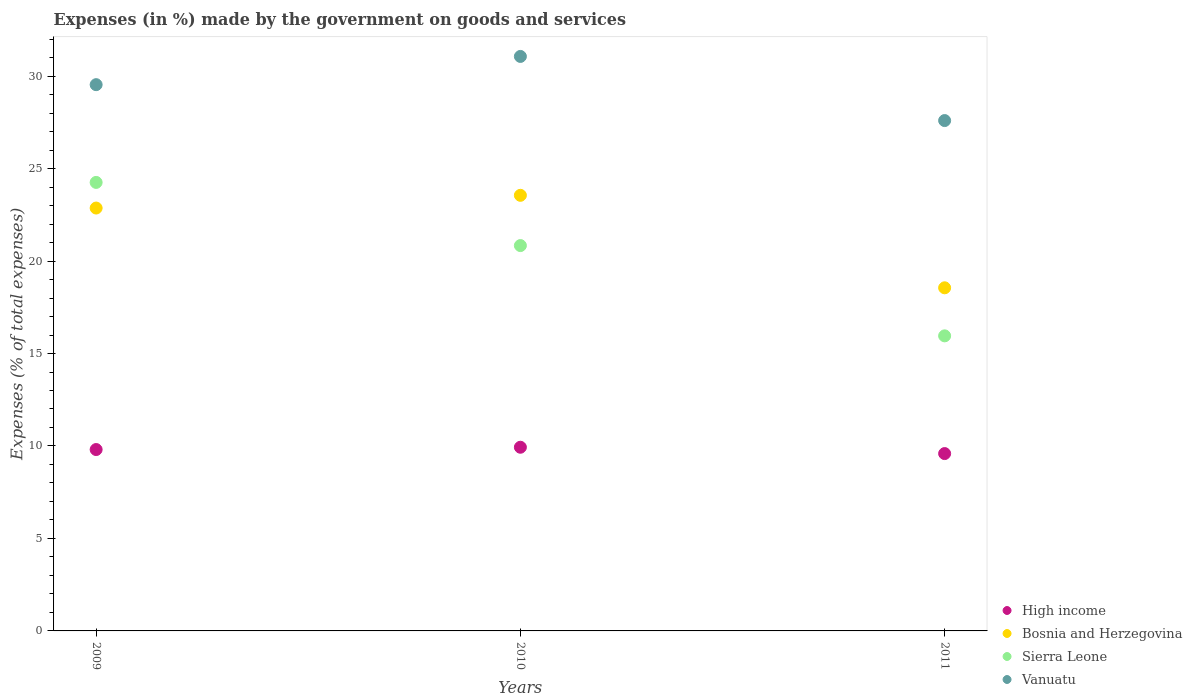How many different coloured dotlines are there?
Make the answer very short. 4. What is the percentage of expenses made by the government on goods and services in Vanuatu in 2010?
Provide a short and direct response. 31.06. Across all years, what is the maximum percentage of expenses made by the government on goods and services in High income?
Ensure brevity in your answer.  9.93. Across all years, what is the minimum percentage of expenses made by the government on goods and services in Vanuatu?
Your answer should be compact. 27.6. In which year was the percentage of expenses made by the government on goods and services in Bosnia and Herzegovina maximum?
Your answer should be compact. 2010. In which year was the percentage of expenses made by the government on goods and services in Sierra Leone minimum?
Your response must be concise. 2011. What is the total percentage of expenses made by the government on goods and services in High income in the graph?
Offer a terse response. 29.33. What is the difference between the percentage of expenses made by the government on goods and services in Bosnia and Herzegovina in 2009 and that in 2010?
Your answer should be very brief. -0.69. What is the difference between the percentage of expenses made by the government on goods and services in High income in 2011 and the percentage of expenses made by the government on goods and services in Bosnia and Herzegovina in 2010?
Give a very brief answer. -13.96. What is the average percentage of expenses made by the government on goods and services in Sierra Leone per year?
Make the answer very short. 20.35. In the year 2011, what is the difference between the percentage of expenses made by the government on goods and services in Sierra Leone and percentage of expenses made by the government on goods and services in Vanuatu?
Your response must be concise. -11.64. What is the ratio of the percentage of expenses made by the government on goods and services in Sierra Leone in 2009 to that in 2011?
Make the answer very short. 1.52. What is the difference between the highest and the second highest percentage of expenses made by the government on goods and services in Vanuatu?
Ensure brevity in your answer.  1.53. What is the difference between the highest and the lowest percentage of expenses made by the government on goods and services in Bosnia and Herzegovina?
Provide a short and direct response. 5. Is the sum of the percentage of expenses made by the government on goods and services in Bosnia and Herzegovina in 2009 and 2011 greater than the maximum percentage of expenses made by the government on goods and services in High income across all years?
Offer a very short reply. Yes. Is it the case that in every year, the sum of the percentage of expenses made by the government on goods and services in Vanuatu and percentage of expenses made by the government on goods and services in Sierra Leone  is greater than the percentage of expenses made by the government on goods and services in Bosnia and Herzegovina?
Your response must be concise. Yes. Does the percentage of expenses made by the government on goods and services in Sierra Leone monotonically increase over the years?
Keep it short and to the point. No. How many years are there in the graph?
Your answer should be compact. 3. What is the difference between two consecutive major ticks on the Y-axis?
Provide a short and direct response. 5. Does the graph contain any zero values?
Provide a short and direct response. No. What is the title of the graph?
Offer a terse response. Expenses (in %) made by the government on goods and services. What is the label or title of the X-axis?
Your answer should be compact. Years. What is the label or title of the Y-axis?
Give a very brief answer. Expenses (% of total expenses). What is the Expenses (% of total expenses) in High income in 2009?
Your answer should be very brief. 9.81. What is the Expenses (% of total expenses) in Bosnia and Herzegovina in 2009?
Provide a succinct answer. 22.87. What is the Expenses (% of total expenses) of Sierra Leone in 2009?
Offer a very short reply. 24.25. What is the Expenses (% of total expenses) of Vanuatu in 2009?
Give a very brief answer. 29.54. What is the Expenses (% of total expenses) in High income in 2010?
Your answer should be compact. 9.93. What is the Expenses (% of total expenses) in Bosnia and Herzegovina in 2010?
Offer a very short reply. 23.55. What is the Expenses (% of total expenses) in Sierra Leone in 2010?
Provide a succinct answer. 20.84. What is the Expenses (% of total expenses) in Vanuatu in 2010?
Provide a succinct answer. 31.06. What is the Expenses (% of total expenses) in High income in 2011?
Provide a succinct answer. 9.59. What is the Expenses (% of total expenses) in Bosnia and Herzegovina in 2011?
Provide a short and direct response. 18.55. What is the Expenses (% of total expenses) in Sierra Leone in 2011?
Your answer should be very brief. 15.95. What is the Expenses (% of total expenses) of Vanuatu in 2011?
Your response must be concise. 27.6. Across all years, what is the maximum Expenses (% of total expenses) of High income?
Keep it short and to the point. 9.93. Across all years, what is the maximum Expenses (% of total expenses) in Bosnia and Herzegovina?
Your answer should be very brief. 23.55. Across all years, what is the maximum Expenses (% of total expenses) in Sierra Leone?
Provide a short and direct response. 24.25. Across all years, what is the maximum Expenses (% of total expenses) in Vanuatu?
Your response must be concise. 31.06. Across all years, what is the minimum Expenses (% of total expenses) of High income?
Your response must be concise. 9.59. Across all years, what is the minimum Expenses (% of total expenses) of Bosnia and Herzegovina?
Give a very brief answer. 18.55. Across all years, what is the minimum Expenses (% of total expenses) in Sierra Leone?
Your answer should be compact. 15.95. Across all years, what is the minimum Expenses (% of total expenses) in Vanuatu?
Give a very brief answer. 27.6. What is the total Expenses (% of total expenses) of High income in the graph?
Your answer should be compact. 29.33. What is the total Expenses (% of total expenses) of Bosnia and Herzegovina in the graph?
Your response must be concise. 64.97. What is the total Expenses (% of total expenses) of Sierra Leone in the graph?
Keep it short and to the point. 61.04. What is the total Expenses (% of total expenses) in Vanuatu in the graph?
Ensure brevity in your answer.  88.19. What is the difference between the Expenses (% of total expenses) in High income in 2009 and that in 2010?
Your answer should be compact. -0.12. What is the difference between the Expenses (% of total expenses) in Bosnia and Herzegovina in 2009 and that in 2010?
Offer a very short reply. -0.69. What is the difference between the Expenses (% of total expenses) of Sierra Leone in 2009 and that in 2010?
Provide a short and direct response. 3.42. What is the difference between the Expenses (% of total expenses) in Vanuatu in 2009 and that in 2010?
Your answer should be very brief. -1.53. What is the difference between the Expenses (% of total expenses) of High income in 2009 and that in 2011?
Provide a succinct answer. 0.22. What is the difference between the Expenses (% of total expenses) in Bosnia and Herzegovina in 2009 and that in 2011?
Your answer should be compact. 4.31. What is the difference between the Expenses (% of total expenses) of Sierra Leone in 2009 and that in 2011?
Your answer should be compact. 8.3. What is the difference between the Expenses (% of total expenses) in Vanuatu in 2009 and that in 2011?
Your response must be concise. 1.94. What is the difference between the Expenses (% of total expenses) of High income in 2010 and that in 2011?
Make the answer very short. 0.34. What is the difference between the Expenses (% of total expenses) in Bosnia and Herzegovina in 2010 and that in 2011?
Provide a short and direct response. 5. What is the difference between the Expenses (% of total expenses) of Sierra Leone in 2010 and that in 2011?
Offer a very short reply. 4.88. What is the difference between the Expenses (% of total expenses) of Vanuatu in 2010 and that in 2011?
Your answer should be compact. 3.47. What is the difference between the Expenses (% of total expenses) in High income in 2009 and the Expenses (% of total expenses) in Bosnia and Herzegovina in 2010?
Provide a short and direct response. -13.75. What is the difference between the Expenses (% of total expenses) in High income in 2009 and the Expenses (% of total expenses) in Sierra Leone in 2010?
Make the answer very short. -11.03. What is the difference between the Expenses (% of total expenses) in High income in 2009 and the Expenses (% of total expenses) in Vanuatu in 2010?
Your answer should be very brief. -21.26. What is the difference between the Expenses (% of total expenses) of Bosnia and Herzegovina in 2009 and the Expenses (% of total expenses) of Sierra Leone in 2010?
Your response must be concise. 2.03. What is the difference between the Expenses (% of total expenses) in Bosnia and Herzegovina in 2009 and the Expenses (% of total expenses) in Vanuatu in 2010?
Give a very brief answer. -8.2. What is the difference between the Expenses (% of total expenses) in Sierra Leone in 2009 and the Expenses (% of total expenses) in Vanuatu in 2010?
Keep it short and to the point. -6.81. What is the difference between the Expenses (% of total expenses) of High income in 2009 and the Expenses (% of total expenses) of Bosnia and Herzegovina in 2011?
Keep it short and to the point. -8.75. What is the difference between the Expenses (% of total expenses) in High income in 2009 and the Expenses (% of total expenses) in Sierra Leone in 2011?
Offer a terse response. -6.15. What is the difference between the Expenses (% of total expenses) of High income in 2009 and the Expenses (% of total expenses) of Vanuatu in 2011?
Ensure brevity in your answer.  -17.79. What is the difference between the Expenses (% of total expenses) in Bosnia and Herzegovina in 2009 and the Expenses (% of total expenses) in Sierra Leone in 2011?
Ensure brevity in your answer.  6.91. What is the difference between the Expenses (% of total expenses) of Bosnia and Herzegovina in 2009 and the Expenses (% of total expenses) of Vanuatu in 2011?
Make the answer very short. -4.73. What is the difference between the Expenses (% of total expenses) in Sierra Leone in 2009 and the Expenses (% of total expenses) in Vanuatu in 2011?
Keep it short and to the point. -3.34. What is the difference between the Expenses (% of total expenses) of High income in 2010 and the Expenses (% of total expenses) of Bosnia and Herzegovina in 2011?
Ensure brevity in your answer.  -8.62. What is the difference between the Expenses (% of total expenses) of High income in 2010 and the Expenses (% of total expenses) of Sierra Leone in 2011?
Make the answer very short. -6.02. What is the difference between the Expenses (% of total expenses) of High income in 2010 and the Expenses (% of total expenses) of Vanuatu in 2011?
Make the answer very short. -17.66. What is the difference between the Expenses (% of total expenses) of Bosnia and Herzegovina in 2010 and the Expenses (% of total expenses) of Sierra Leone in 2011?
Provide a succinct answer. 7.6. What is the difference between the Expenses (% of total expenses) of Bosnia and Herzegovina in 2010 and the Expenses (% of total expenses) of Vanuatu in 2011?
Ensure brevity in your answer.  -4.04. What is the difference between the Expenses (% of total expenses) in Sierra Leone in 2010 and the Expenses (% of total expenses) in Vanuatu in 2011?
Give a very brief answer. -6.76. What is the average Expenses (% of total expenses) in High income per year?
Keep it short and to the point. 9.78. What is the average Expenses (% of total expenses) in Bosnia and Herzegovina per year?
Keep it short and to the point. 21.66. What is the average Expenses (% of total expenses) in Sierra Leone per year?
Give a very brief answer. 20.35. What is the average Expenses (% of total expenses) of Vanuatu per year?
Provide a short and direct response. 29.4. In the year 2009, what is the difference between the Expenses (% of total expenses) in High income and Expenses (% of total expenses) in Bosnia and Herzegovina?
Ensure brevity in your answer.  -13.06. In the year 2009, what is the difference between the Expenses (% of total expenses) of High income and Expenses (% of total expenses) of Sierra Leone?
Keep it short and to the point. -14.44. In the year 2009, what is the difference between the Expenses (% of total expenses) of High income and Expenses (% of total expenses) of Vanuatu?
Provide a short and direct response. -19.73. In the year 2009, what is the difference between the Expenses (% of total expenses) of Bosnia and Herzegovina and Expenses (% of total expenses) of Sierra Leone?
Provide a short and direct response. -1.39. In the year 2009, what is the difference between the Expenses (% of total expenses) of Bosnia and Herzegovina and Expenses (% of total expenses) of Vanuatu?
Ensure brevity in your answer.  -6.67. In the year 2009, what is the difference between the Expenses (% of total expenses) in Sierra Leone and Expenses (% of total expenses) in Vanuatu?
Your response must be concise. -5.29. In the year 2010, what is the difference between the Expenses (% of total expenses) of High income and Expenses (% of total expenses) of Bosnia and Herzegovina?
Give a very brief answer. -13.62. In the year 2010, what is the difference between the Expenses (% of total expenses) in High income and Expenses (% of total expenses) in Sierra Leone?
Keep it short and to the point. -10.9. In the year 2010, what is the difference between the Expenses (% of total expenses) of High income and Expenses (% of total expenses) of Vanuatu?
Provide a succinct answer. -21.13. In the year 2010, what is the difference between the Expenses (% of total expenses) in Bosnia and Herzegovina and Expenses (% of total expenses) in Sierra Leone?
Your answer should be compact. 2.72. In the year 2010, what is the difference between the Expenses (% of total expenses) in Bosnia and Herzegovina and Expenses (% of total expenses) in Vanuatu?
Provide a short and direct response. -7.51. In the year 2010, what is the difference between the Expenses (% of total expenses) of Sierra Leone and Expenses (% of total expenses) of Vanuatu?
Offer a terse response. -10.23. In the year 2011, what is the difference between the Expenses (% of total expenses) in High income and Expenses (% of total expenses) in Bosnia and Herzegovina?
Provide a succinct answer. -8.96. In the year 2011, what is the difference between the Expenses (% of total expenses) in High income and Expenses (% of total expenses) in Sierra Leone?
Ensure brevity in your answer.  -6.37. In the year 2011, what is the difference between the Expenses (% of total expenses) of High income and Expenses (% of total expenses) of Vanuatu?
Ensure brevity in your answer.  -18.01. In the year 2011, what is the difference between the Expenses (% of total expenses) of Bosnia and Herzegovina and Expenses (% of total expenses) of Sierra Leone?
Your answer should be very brief. 2.6. In the year 2011, what is the difference between the Expenses (% of total expenses) in Bosnia and Herzegovina and Expenses (% of total expenses) in Vanuatu?
Provide a succinct answer. -9.04. In the year 2011, what is the difference between the Expenses (% of total expenses) of Sierra Leone and Expenses (% of total expenses) of Vanuatu?
Your answer should be compact. -11.64. What is the ratio of the Expenses (% of total expenses) in High income in 2009 to that in 2010?
Make the answer very short. 0.99. What is the ratio of the Expenses (% of total expenses) in Bosnia and Herzegovina in 2009 to that in 2010?
Your answer should be compact. 0.97. What is the ratio of the Expenses (% of total expenses) in Sierra Leone in 2009 to that in 2010?
Offer a terse response. 1.16. What is the ratio of the Expenses (% of total expenses) in Vanuatu in 2009 to that in 2010?
Offer a terse response. 0.95. What is the ratio of the Expenses (% of total expenses) of High income in 2009 to that in 2011?
Provide a succinct answer. 1.02. What is the ratio of the Expenses (% of total expenses) of Bosnia and Herzegovina in 2009 to that in 2011?
Offer a very short reply. 1.23. What is the ratio of the Expenses (% of total expenses) in Sierra Leone in 2009 to that in 2011?
Your answer should be compact. 1.52. What is the ratio of the Expenses (% of total expenses) of Vanuatu in 2009 to that in 2011?
Offer a very short reply. 1.07. What is the ratio of the Expenses (% of total expenses) in High income in 2010 to that in 2011?
Provide a short and direct response. 1.04. What is the ratio of the Expenses (% of total expenses) of Bosnia and Herzegovina in 2010 to that in 2011?
Your answer should be compact. 1.27. What is the ratio of the Expenses (% of total expenses) of Sierra Leone in 2010 to that in 2011?
Your response must be concise. 1.31. What is the ratio of the Expenses (% of total expenses) of Vanuatu in 2010 to that in 2011?
Your response must be concise. 1.13. What is the difference between the highest and the second highest Expenses (% of total expenses) of High income?
Your answer should be very brief. 0.12. What is the difference between the highest and the second highest Expenses (% of total expenses) of Bosnia and Herzegovina?
Make the answer very short. 0.69. What is the difference between the highest and the second highest Expenses (% of total expenses) in Sierra Leone?
Provide a short and direct response. 3.42. What is the difference between the highest and the second highest Expenses (% of total expenses) in Vanuatu?
Provide a short and direct response. 1.53. What is the difference between the highest and the lowest Expenses (% of total expenses) of High income?
Your answer should be compact. 0.34. What is the difference between the highest and the lowest Expenses (% of total expenses) of Bosnia and Herzegovina?
Give a very brief answer. 5. What is the difference between the highest and the lowest Expenses (% of total expenses) in Sierra Leone?
Provide a succinct answer. 8.3. What is the difference between the highest and the lowest Expenses (% of total expenses) of Vanuatu?
Give a very brief answer. 3.47. 